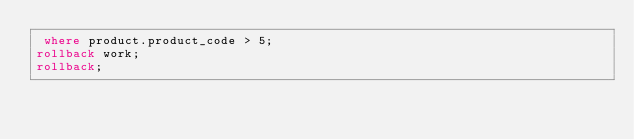Convert code to text. <code><loc_0><loc_0><loc_500><loc_500><_SQL_> where product.product_code > 5;
rollback work;
rollback;
</code> 